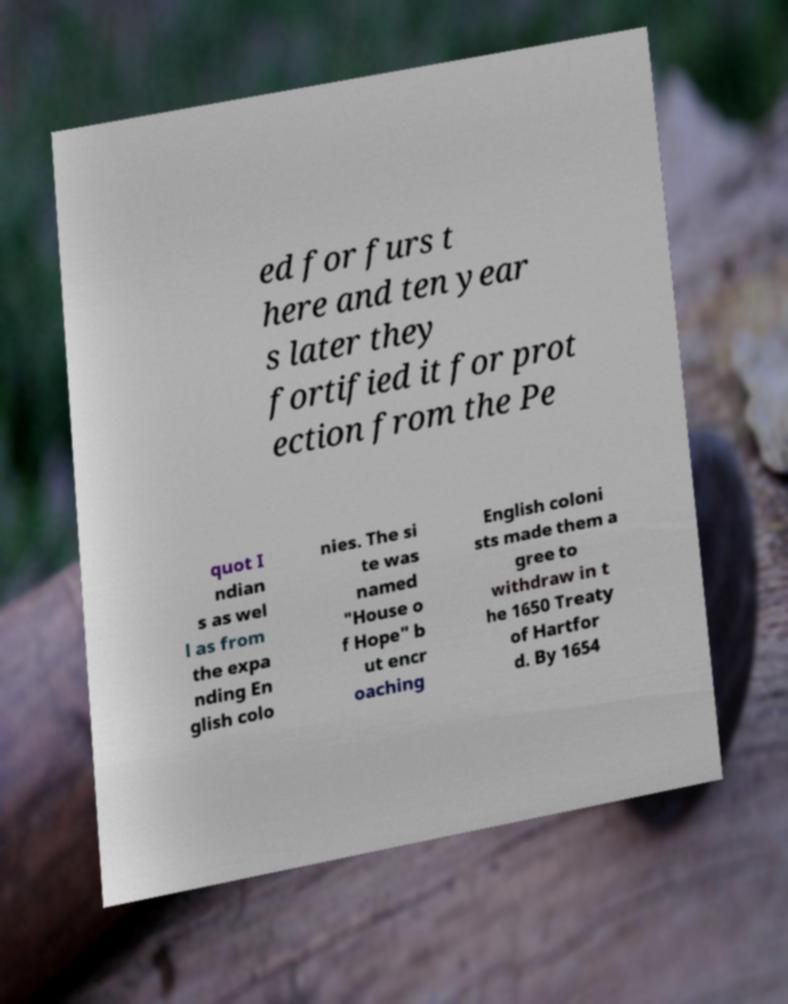There's text embedded in this image that I need extracted. Can you transcribe it verbatim? ed for furs t here and ten year s later they fortified it for prot ection from the Pe quot I ndian s as wel l as from the expa nding En glish colo nies. The si te was named "House o f Hope" b ut encr oaching English coloni sts made them a gree to withdraw in t he 1650 Treaty of Hartfor d. By 1654 